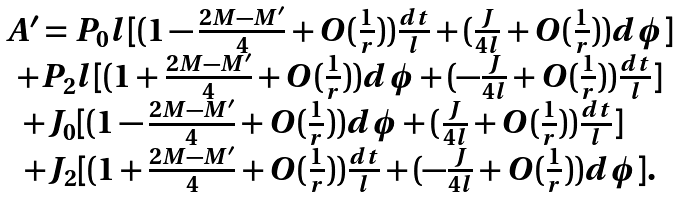<formula> <loc_0><loc_0><loc_500><loc_500>\begin{array} { c } A ^ { \prime } = P _ { 0 } l [ ( 1 - \frac { 2 M - M ^ { \prime } } { 4 } + O ( \frac { 1 } { r } ) ) \frac { d t } { l } + ( \frac { J } { 4 l } + O ( \frac { 1 } { r } ) ) d \phi ] \\ + P _ { 2 } l [ ( 1 + \frac { 2 M - M ^ { \prime } } { 4 } + O ( \frac { 1 } { r } ) ) d \phi + ( - \frac { J } { 4 l } + O ( \frac { 1 } { r } ) ) \frac { d t } { l } ] \\ + J _ { 0 } [ ( 1 - \frac { 2 M - M ^ { \prime } } { 4 } + O ( \frac { 1 } { r } ) ) d \phi + ( \frac { J } { 4 l } + O ( \frac { 1 } { r } ) ) \frac { d t } { l } ] \quad \\ + J _ { 2 } [ ( 1 + \frac { 2 M - M ^ { \prime } } { 4 } + O ( \frac { 1 } { r } ) ) \frac { d t } { l } + ( - \frac { J } { 4 l } + O ( \frac { 1 } { r } ) ) d \phi ] . \end{array}</formula> 